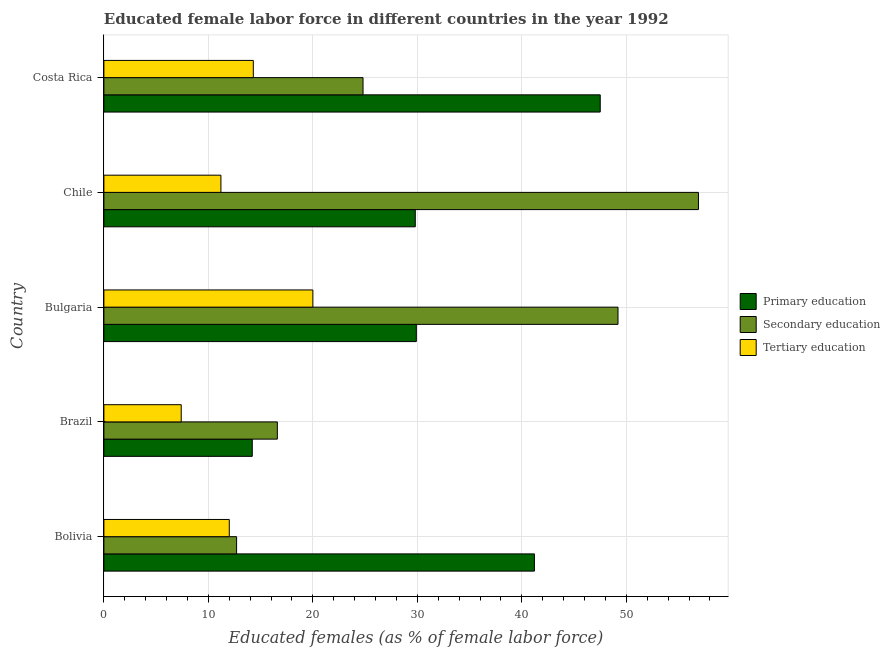How many different coloured bars are there?
Your answer should be compact. 3. Are the number of bars per tick equal to the number of legend labels?
Provide a short and direct response. Yes. What is the label of the 3rd group of bars from the top?
Your answer should be very brief. Bulgaria. In how many cases, is the number of bars for a given country not equal to the number of legend labels?
Ensure brevity in your answer.  0. What is the percentage of female labor force who received secondary education in Costa Rica?
Make the answer very short. 24.8. Across all countries, what is the maximum percentage of female labor force who received tertiary education?
Your answer should be compact. 20. Across all countries, what is the minimum percentage of female labor force who received secondary education?
Your response must be concise. 12.7. In which country was the percentage of female labor force who received secondary education maximum?
Your answer should be compact. Chile. In which country was the percentage of female labor force who received tertiary education minimum?
Your response must be concise. Brazil. What is the total percentage of female labor force who received secondary education in the graph?
Your answer should be very brief. 160.2. What is the difference between the percentage of female labor force who received tertiary education in Costa Rica and the percentage of female labor force who received primary education in Chile?
Your answer should be compact. -15.5. What is the average percentage of female labor force who received tertiary education per country?
Your response must be concise. 12.98. What is the difference between the percentage of female labor force who received secondary education and percentage of female labor force who received tertiary education in Costa Rica?
Ensure brevity in your answer.  10.5. What is the ratio of the percentage of female labor force who received tertiary education in Bulgaria to that in Chile?
Provide a succinct answer. 1.79. Is the percentage of female labor force who received primary education in Brazil less than that in Bulgaria?
Your answer should be compact. Yes. What is the difference between the highest and the second highest percentage of female labor force who received tertiary education?
Keep it short and to the point. 5.7. What is the difference between the highest and the lowest percentage of female labor force who received tertiary education?
Your answer should be compact. 12.6. In how many countries, is the percentage of female labor force who received primary education greater than the average percentage of female labor force who received primary education taken over all countries?
Make the answer very short. 2. Is the sum of the percentage of female labor force who received tertiary education in Bolivia and Bulgaria greater than the maximum percentage of female labor force who received secondary education across all countries?
Your response must be concise. No. What does the 3rd bar from the top in Costa Rica represents?
Your answer should be compact. Primary education. What does the 1st bar from the bottom in Bolivia represents?
Offer a very short reply. Primary education. Is it the case that in every country, the sum of the percentage of female labor force who received primary education and percentage of female labor force who received secondary education is greater than the percentage of female labor force who received tertiary education?
Keep it short and to the point. Yes. Are all the bars in the graph horizontal?
Your answer should be very brief. Yes. Are the values on the major ticks of X-axis written in scientific E-notation?
Offer a terse response. No. Does the graph contain any zero values?
Give a very brief answer. No. Where does the legend appear in the graph?
Your answer should be compact. Center right. How are the legend labels stacked?
Make the answer very short. Vertical. What is the title of the graph?
Your answer should be very brief. Educated female labor force in different countries in the year 1992. Does "Total employers" appear as one of the legend labels in the graph?
Your answer should be compact. No. What is the label or title of the X-axis?
Provide a succinct answer. Educated females (as % of female labor force). What is the label or title of the Y-axis?
Give a very brief answer. Country. What is the Educated females (as % of female labor force) of Primary education in Bolivia?
Offer a very short reply. 41.2. What is the Educated females (as % of female labor force) in Secondary education in Bolivia?
Provide a succinct answer. 12.7. What is the Educated females (as % of female labor force) in Tertiary education in Bolivia?
Ensure brevity in your answer.  12. What is the Educated females (as % of female labor force) of Primary education in Brazil?
Make the answer very short. 14.2. What is the Educated females (as % of female labor force) in Secondary education in Brazil?
Ensure brevity in your answer.  16.6. What is the Educated females (as % of female labor force) in Tertiary education in Brazil?
Make the answer very short. 7.4. What is the Educated females (as % of female labor force) of Primary education in Bulgaria?
Your response must be concise. 29.9. What is the Educated females (as % of female labor force) of Secondary education in Bulgaria?
Offer a very short reply. 49.2. What is the Educated females (as % of female labor force) in Primary education in Chile?
Your answer should be very brief. 29.8. What is the Educated females (as % of female labor force) of Secondary education in Chile?
Your answer should be very brief. 56.9. What is the Educated females (as % of female labor force) in Tertiary education in Chile?
Give a very brief answer. 11.2. What is the Educated females (as % of female labor force) in Primary education in Costa Rica?
Make the answer very short. 47.5. What is the Educated females (as % of female labor force) of Secondary education in Costa Rica?
Give a very brief answer. 24.8. What is the Educated females (as % of female labor force) of Tertiary education in Costa Rica?
Provide a succinct answer. 14.3. Across all countries, what is the maximum Educated females (as % of female labor force) of Primary education?
Make the answer very short. 47.5. Across all countries, what is the maximum Educated females (as % of female labor force) of Secondary education?
Keep it short and to the point. 56.9. Across all countries, what is the minimum Educated females (as % of female labor force) in Primary education?
Give a very brief answer. 14.2. Across all countries, what is the minimum Educated females (as % of female labor force) in Secondary education?
Give a very brief answer. 12.7. Across all countries, what is the minimum Educated females (as % of female labor force) of Tertiary education?
Offer a terse response. 7.4. What is the total Educated females (as % of female labor force) of Primary education in the graph?
Offer a terse response. 162.6. What is the total Educated females (as % of female labor force) of Secondary education in the graph?
Your answer should be compact. 160.2. What is the total Educated females (as % of female labor force) in Tertiary education in the graph?
Provide a succinct answer. 64.9. What is the difference between the Educated females (as % of female labor force) of Primary education in Bolivia and that in Brazil?
Provide a succinct answer. 27. What is the difference between the Educated females (as % of female labor force) in Secondary education in Bolivia and that in Brazil?
Provide a succinct answer. -3.9. What is the difference between the Educated females (as % of female labor force) of Tertiary education in Bolivia and that in Brazil?
Offer a terse response. 4.6. What is the difference between the Educated females (as % of female labor force) in Primary education in Bolivia and that in Bulgaria?
Your answer should be very brief. 11.3. What is the difference between the Educated females (as % of female labor force) of Secondary education in Bolivia and that in Bulgaria?
Your answer should be compact. -36.5. What is the difference between the Educated females (as % of female labor force) in Primary education in Bolivia and that in Chile?
Provide a short and direct response. 11.4. What is the difference between the Educated females (as % of female labor force) in Secondary education in Bolivia and that in Chile?
Provide a succinct answer. -44.2. What is the difference between the Educated females (as % of female labor force) of Tertiary education in Bolivia and that in Costa Rica?
Your answer should be very brief. -2.3. What is the difference between the Educated females (as % of female labor force) of Primary education in Brazil and that in Bulgaria?
Give a very brief answer. -15.7. What is the difference between the Educated females (as % of female labor force) of Secondary education in Brazil and that in Bulgaria?
Ensure brevity in your answer.  -32.6. What is the difference between the Educated females (as % of female labor force) of Tertiary education in Brazil and that in Bulgaria?
Provide a succinct answer. -12.6. What is the difference between the Educated females (as % of female labor force) of Primary education in Brazil and that in Chile?
Offer a very short reply. -15.6. What is the difference between the Educated females (as % of female labor force) in Secondary education in Brazil and that in Chile?
Your answer should be very brief. -40.3. What is the difference between the Educated females (as % of female labor force) of Tertiary education in Brazil and that in Chile?
Offer a terse response. -3.8. What is the difference between the Educated females (as % of female labor force) of Primary education in Brazil and that in Costa Rica?
Make the answer very short. -33.3. What is the difference between the Educated females (as % of female labor force) of Secondary education in Brazil and that in Costa Rica?
Your answer should be compact. -8.2. What is the difference between the Educated females (as % of female labor force) in Tertiary education in Bulgaria and that in Chile?
Keep it short and to the point. 8.8. What is the difference between the Educated females (as % of female labor force) in Primary education in Bulgaria and that in Costa Rica?
Provide a succinct answer. -17.6. What is the difference between the Educated females (as % of female labor force) in Secondary education in Bulgaria and that in Costa Rica?
Offer a very short reply. 24.4. What is the difference between the Educated females (as % of female labor force) of Tertiary education in Bulgaria and that in Costa Rica?
Your answer should be compact. 5.7. What is the difference between the Educated females (as % of female labor force) of Primary education in Chile and that in Costa Rica?
Ensure brevity in your answer.  -17.7. What is the difference between the Educated females (as % of female labor force) of Secondary education in Chile and that in Costa Rica?
Give a very brief answer. 32.1. What is the difference between the Educated females (as % of female labor force) of Primary education in Bolivia and the Educated females (as % of female labor force) of Secondary education in Brazil?
Your answer should be compact. 24.6. What is the difference between the Educated females (as % of female labor force) of Primary education in Bolivia and the Educated females (as % of female labor force) of Tertiary education in Brazil?
Make the answer very short. 33.8. What is the difference between the Educated females (as % of female labor force) of Secondary education in Bolivia and the Educated females (as % of female labor force) of Tertiary education in Brazil?
Your response must be concise. 5.3. What is the difference between the Educated females (as % of female labor force) of Primary education in Bolivia and the Educated females (as % of female labor force) of Secondary education in Bulgaria?
Give a very brief answer. -8. What is the difference between the Educated females (as % of female labor force) of Primary education in Bolivia and the Educated females (as % of female labor force) of Tertiary education in Bulgaria?
Give a very brief answer. 21.2. What is the difference between the Educated females (as % of female labor force) in Primary education in Bolivia and the Educated females (as % of female labor force) in Secondary education in Chile?
Offer a very short reply. -15.7. What is the difference between the Educated females (as % of female labor force) of Primary education in Bolivia and the Educated females (as % of female labor force) of Secondary education in Costa Rica?
Offer a terse response. 16.4. What is the difference between the Educated females (as % of female labor force) of Primary education in Bolivia and the Educated females (as % of female labor force) of Tertiary education in Costa Rica?
Your answer should be compact. 26.9. What is the difference between the Educated females (as % of female labor force) in Primary education in Brazil and the Educated females (as % of female labor force) in Secondary education in Bulgaria?
Your answer should be compact. -35. What is the difference between the Educated females (as % of female labor force) of Primary education in Brazil and the Educated females (as % of female labor force) of Tertiary education in Bulgaria?
Keep it short and to the point. -5.8. What is the difference between the Educated females (as % of female labor force) of Secondary education in Brazil and the Educated females (as % of female labor force) of Tertiary education in Bulgaria?
Ensure brevity in your answer.  -3.4. What is the difference between the Educated females (as % of female labor force) of Primary education in Brazil and the Educated females (as % of female labor force) of Secondary education in Chile?
Ensure brevity in your answer.  -42.7. What is the difference between the Educated females (as % of female labor force) of Secondary education in Brazil and the Educated females (as % of female labor force) of Tertiary education in Chile?
Make the answer very short. 5.4. What is the difference between the Educated females (as % of female labor force) of Primary education in Brazil and the Educated females (as % of female labor force) of Secondary education in Costa Rica?
Provide a succinct answer. -10.6. What is the difference between the Educated females (as % of female labor force) of Secondary education in Bulgaria and the Educated females (as % of female labor force) of Tertiary education in Chile?
Your answer should be very brief. 38. What is the difference between the Educated females (as % of female labor force) of Secondary education in Bulgaria and the Educated females (as % of female labor force) of Tertiary education in Costa Rica?
Offer a very short reply. 34.9. What is the difference between the Educated females (as % of female labor force) of Primary education in Chile and the Educated females (as % of female labor force) of Tertiary education in Costa Rica?
Offer a terse response. 15.5. What is the difference between the Educated females (as % of female labor force) of Secondary education in Chile and the Educated females (as % of female labor force) of Tertiary education in Costa Rica?
Your answer should be very brief. 42.6. What is the average Educated females (as % of female labor force) in Primary education per country?
Offer a very short reply. 32.52. What is the average Educated females (as % of female labor force) of Secondary education per country?
Provide a succinct answer. 32.04. What is the average Educated females (as % of female labor force) of Tertiary education per country?
Provide a succinct answer. 12.98. What is the difference between the Educated females (as % of female labor force) of Primary education and Educated females (as % of female labor force) of Secondary education in Bolivia?
Provide a short and direct response. 28.5. What is the difference between the Educated females (as % of female labor force) in Primary education and Educated females (as % of female labor force) in Tertiary education in Bolivia?
Your answer should be compact. 29.2. What is the difference between the Educated females (as % of female labor force) of Secondary education and Educated females (as % of female labor force) of Tertiary education in Brazil?
Offer a very short reply. 9.2. What is the difference between the Educated females (as % of female labor force) of Primary education and Educated females (as % of female labor force) of Secondary education in Bulgaria?
Provide a succinct answer. -19.3. What is the difference between the Educated females (as % of female labor force) of Secondary education and Educated females (as % of female labor force) of Tertiary education in Bulgaria?
Your answer should be very brief. 29.2. What is the difference between the Educated females (as % of female labor force) in Primary education and Educated females (as % of female labor force) in Secondary education in Chile?
Your answer should be very brief. -27.1. What is the difference between the Educated females (as % of female labor force) in Primary education and Educated females (as % of female labor force) in Tertiary education in Chile?
Make the answer very short. 18.6. What is the difference between the Educated females (as % of female labor force) of Secondary education and Educated females (as % of female labor force) of Tertiary education in Chile?
Provide a succinct answer. 45.7. What is the difference between the Educated females (as % of female labor force) in Primary education and Educated females (as % of female labor force) in Secondary education in Costa Rica?
Give a very brief answer. 22.7. What is the difference between the Educated females (as % of female labor force) in Primary education and Educated females (as % of female labor force) in Tertiary education in Costa Rica?
Provide a succinct answer. 33.2. What is the difference between the Educated females (as % of female labor force) of Secondary education and Educated females (as % of female labor force) of Tertiary education in Costa Rica?
Provide a short and direct response. 10.5. What is the ratio of the Educated females (as % of female labor force) in Primary education in Bolivia to that in Brazil?
Your answer should be very brief. 2.9. What is the ratio of the Educated females (as % of female labor force) of Secondary education in Bolivia to that in Brazil?
Your answer should be compact. 0.77. What is the ratio of the Educated females (as % of female labor force) of Tertiary education in Bolivia to that in Brazil?
Ensure brevity in your answer.  1.62. What is the ratio of the Educated females (as % of female labor force) of Primary education in Bolivia to that in Bulgaria?
Ensure brevity in your answer.  1.38. What is the ratio of the Educated females (as % of female labor force) in Secondary education in Bolivia to that in Bulgaria?
Ensure brevity in your answer.  0.26. What is the ratio of the Educated females (as % of female labor force) in Tertiary education in Bolivia to that in Bulgaria?
Keep it short and to the point. 0.6. What is the ratio of the Educated females (as % of female labor force) of Primary education in Bolivia to that in Chile?
Provide a succinct answer. 1.38. What is the ratio of the Educated females (as % of female labor force) of Secondary education in Bolivia to that in Chile?
Make the answer very short. 0.22. What is the ratio of the Educated females (as % of female labor force) in Tertiary education in Bolivia to that in Chile?
Make the answer very short. 1.07. What is the ratio of the Educated females (as % of female labor force) in Primary education in Bolivia to that in Costa Rica?
Give a very brief answer. 0.87. What is the ratio of the Educated females (as % of female labor force) of Secondary education in Bolivia to that in Costa Rica?
Offer a terse response. 0.51. What is the ratio of the Educated females (as % of female labor force) in Tertiary education in Bolivia to that in Costa Rica?
Ensure brevity in your answer.  0.84. What is the ratio of the Educated females (as % of female labor force) of Primary education in Brazil to that in Bulgaria?
Your response must be concise. 0.47. What is the ratio of the Educated females (as % of female labor force) of Secondary education in Brazil to that in Bulgaria?
Your answer should be compact. 0.34. What is the ratio of the Educated females (as % of female labor force) in Tertiary education in Brazil to that in Bulgaria?
Ensure brevity in your answer.  0.37. What is the ratio of the Educated females (as % of female labor force) of Primary education in Brazil to that in Chile?
Your response must be concise. 0.48. What is the ratio of the Educated females (as % of female labor force) of Secondary education in Brazil to that in Chile?
Ensure brevity in your answer.  0.29. What is the ratio of the Educated females (as % of female labor force) of Tertiary education in Brazil to that in Chile?
Offer a terse response. 0.66. What is the ratio of the Educated females (as % of female labor force) in Primary education in Brazil to that in Costa Rica?
Offer a very short reply. 0.3. What is the ratio of the Educated females (as % of female labor force) of Secondary education in Brazil to that in Costa Rica?
Your answer should be compact. 0.67. What is the ratio of the Educated females (as % of female labor force) in Tertiary education in Brazil to that in Costa Rica?
Offer a terse response. 0.52. What is the ratio of the Educated females (as % of female labor force) in Primary education in Bulgaria to that in Chile?
Offer a terse response. 1. What is the ratio of the Educated females (as % of female labor force) of Secondary education in Bulgaria to that in Chile?
Ensure brevity in your answer.  0.86. What is the ratio of the Educated females (as % of female labor force) of Tertiary education in Bulgaria to that in Chile?
Provide a succinct answer. 1.79. What is the ratio of the Educated females (as % of female labor force) of Primary education in Bulgaria to that in Costa Rica?
Ensure brevity in your answer.  0.63. What is the ratio of the Educated females (as % of female labor force) in Secondary education in Bulgaria to that in Costa Rica?
Offer a very short reply. 1.98. What is the ratio of the Educated females (as % of female labor force) in Tertiary education in Bulgaria to that in Costa Rica?
Provide a short and direct response. 1.4. What is the ratio of the Educated females (as % of female labor force) in Primary education in Chile to that in Costa Rica?
Make the answer very short. 0.63. What is the ratio of the Educated females (as % of female labor force) of Secondary education in Chile to that in Costa Rica?
Keep it short and to the point. 2.29. What is the ratio of the Educated females (as % of female labor force) in Tertiary education in Chile to that in Costa Rica?
Your answer should be very brief. 0.78. What is the difference between the highest and the second highest Educated females (as % of female labor force) of Primary education?
Your answer should be very brief. 6.3. What is the difference between the highest and the second highest Educated females (as % of female labor force) in Tertiary education?
Give a very brief answer. 5.7. What is the difference between the highest and the lowest Educated females (as % of female labor force) in Primary education?
Provide a short and direct response. 33.3. What is the difference between the highest and the lowest Educated females (as % of female labor force) in Secondary education?
Give a very brief answer. 44.2. What is the difference between the highest and the lowest Educated females (as % of female labor force) of Tertiary education?
Your answer should be compact. 12.6. 